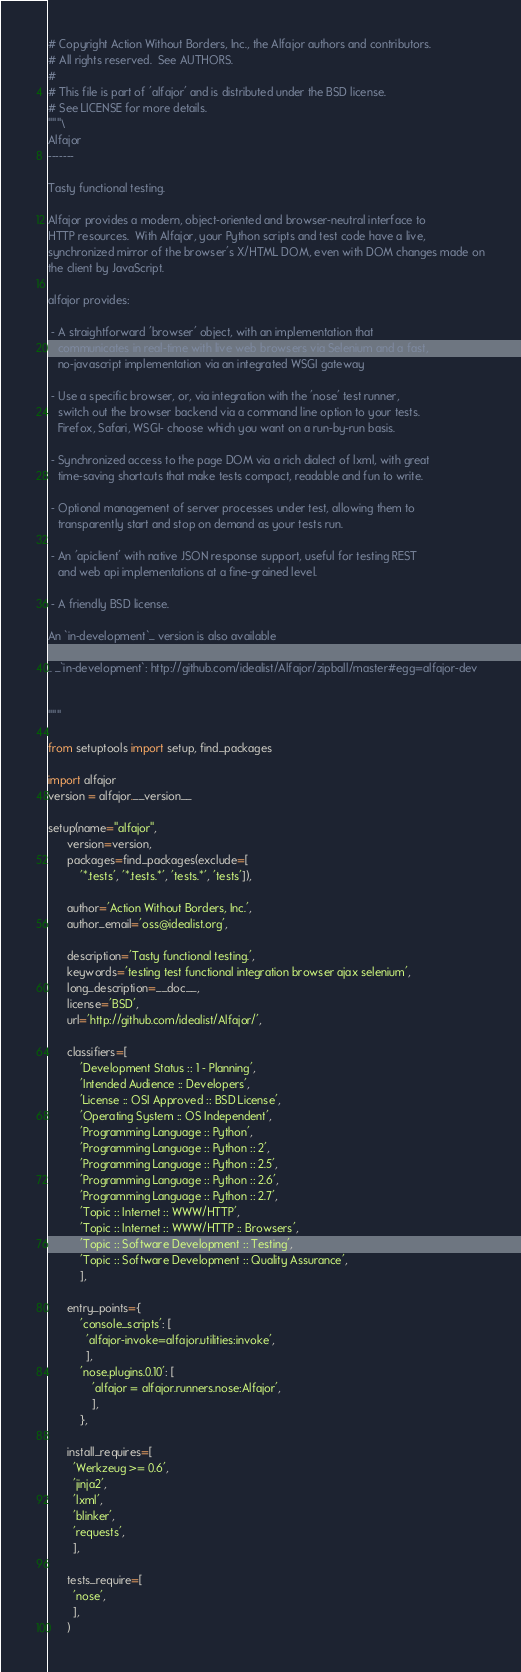Convert code to text. <code><loc_0><loc_0><loc_500><loc_500><_Python_># Copyright Action Without Borders, Inc., the Alfajor authors and contributors.
# All rights reserved.  See AUTHORS.
#
# This file is part of 'alfajor' and is distributed under the BSD license.
# See LICENSE for more details.
"""\
Alfajor
-------

Tasty functional testing.

Alfajor provides a modern, object-oriented and browser-neutral interface to
HTTP resources.  With Alfajor, your Python scripts and test code have a live,
synchronized mirror of the browser's X/HTML DOM, even with DOM changes made on
the client by JavaScript.

alfajor provides:

 - A straightforward 'browser' object, with an implementation that
   communicates in real-time with live web browsers via Selenium and a fast,
   no-javascript implementation via an integrated WSGI gateway

 - Use a specific browser, or, via integration with the 'nose' test runner,
   switch out the browser backend via a command line option to your tests.
   Firefox, Safari, WSGI- choose which you want on a run-by-run basis.

 - Synchronized access to the page DOM via a rich dialect of lxml, with great
   time-saving shortcuts that make tests compact, readable and fun to write.

 - Optional management of server processes under test, allowing them to
   transparently start and stop on demand as your tests run.

 - An 'apiclient' with native JSON response support, useful for testing REST
   and web api implementations at a fine-grained level.

 - A friendly BSD license.

An `in-development`_ version is also available

.. _`in-development`: http://github.com/idealist/Alfajor/zipball/master#egg=alfajor-dev


"""

from setuptools import setup, find_packages

import alfajor
version = alfajor.__version__

setup(name="alfajor",
      version=version,
      packages=find_packages(exclude=[
          '*.tests', '*.tests.*', 'tests.*', 'tests']),

      author='Action Without Borders, Inc.',
      author_email='oss@idealist.org',

      description='Tasty functional testing.',
      keywords='testing test functional integration browser ajax selenium',
      long_description=__doc__,
      license='BSD',
      url='http://github.com/idealist/Alfajor/',

      classifiers=[
          'Development Status :: 1 - Planning',
          'Intended Audience :: Developers',
          'License :: OSI Approved :: BSD License',
          'Operating System :: OS Independent',
          'Programming Language :: Python',
          'Programming Language :: Python :: 2',
          'Programming Language :: Python :: 2.5',
          'Programming Language :: Python :: 2.6',
          'Programming Language :: Python :: 2.7',
          'Topic :: Internet :: WWW/HTTP',
          'Topic :: Internet :: WWW/HTTP :: Browsers',
          'Topic :: Software Development :: Testing',
          'Topic :: Software Development :: Quality Assurance',
          ],

      entry_points={
          'console_scripts': [
            'alfajor-invoke=alfajor.utilities:invoke',
            ],
          'nose.plugins.0.10': [
              'alfajor = alfajor.runners.nose:Alfajor',
              ],
          },

      install_requires=[
        'Werkzeug >= 0.6',
        'jinja2',
        'lxml',
        'blinker',
        'requests',
        ],

      tests_require=[
        'nose',
        ],
      )
</code> 